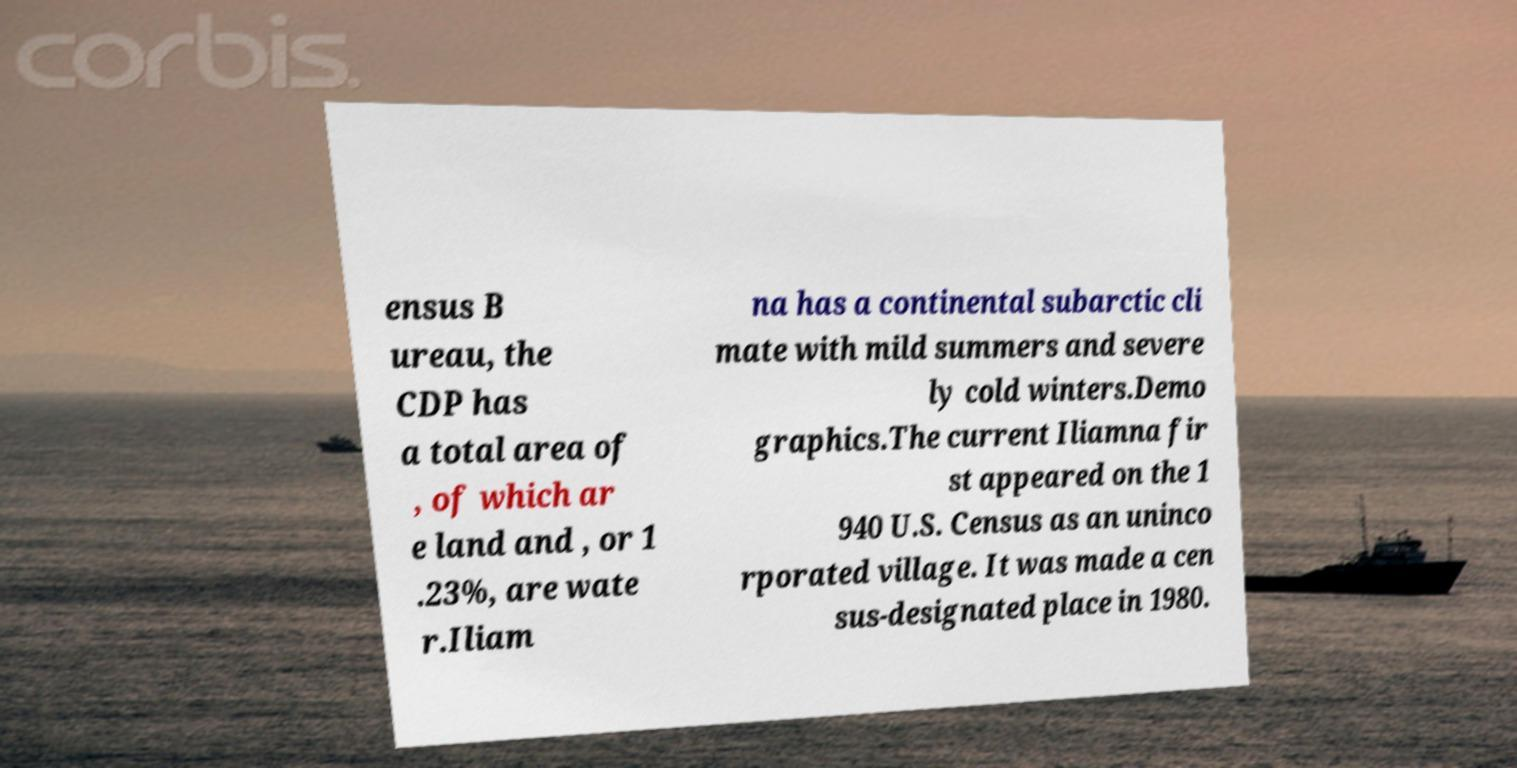Please read and relay the text visible in this image. What does it say? ensus B ureau, the CDP has a total area of , of which ar e land and , or 1 .23%, are wate r.Iliam na has a continental subarctic cli mate with mild summers and severe ly cold winters.Demo graphics.The current Iliamna fir st appeared on the 1 940 U.S. Census as an uninco rporated village. It was made a cen sus-designated place in 1980. 